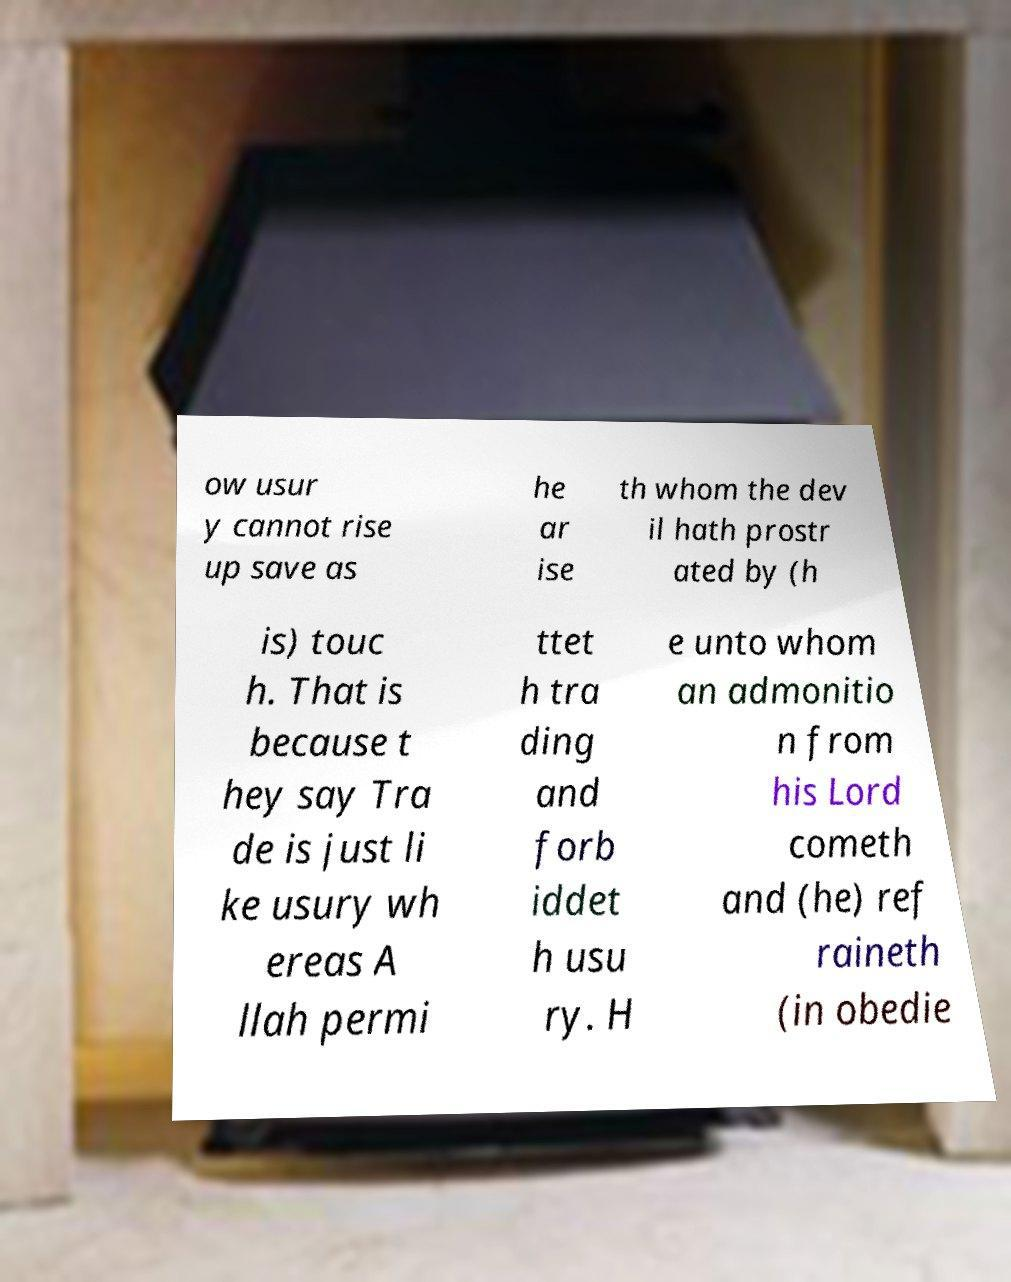Could you extract and type out the text from this image? ow usur y cannot rise up save as he ar ise th whom the dev il hath prostr ated by (h is) touc h. That is because t hey say Tra de is just li ke usury wh ereas A llah permi ttet h tra ding and forb iddet h usu ry. H e unto whom an admonitio n from his Lord cometh and (he) ref raineth (in obedie 